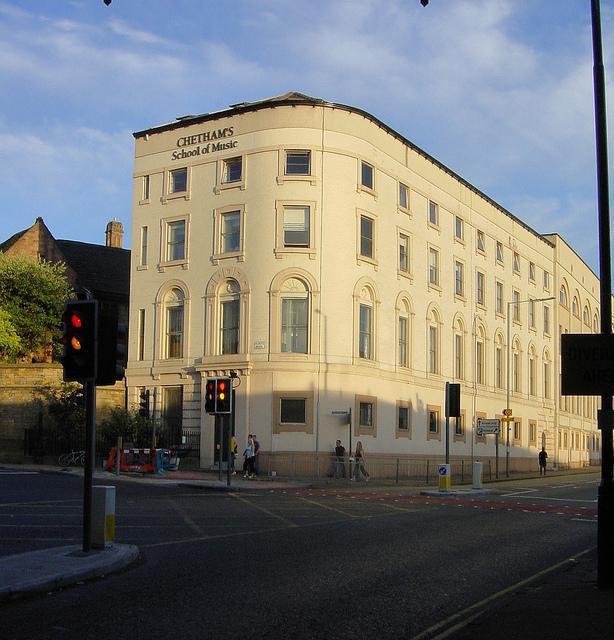How many red lights are showing?
Give a very brief answer. 2. How many traffic lights are there?
Give a very brief answer. 2. How many clocks are in the picture?
Give a very brief answer. 0. 